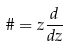<formula> <loc_0><loc_0><loc_500><loc_500>\vartheta = z \frac { d } { d z }</formula> 